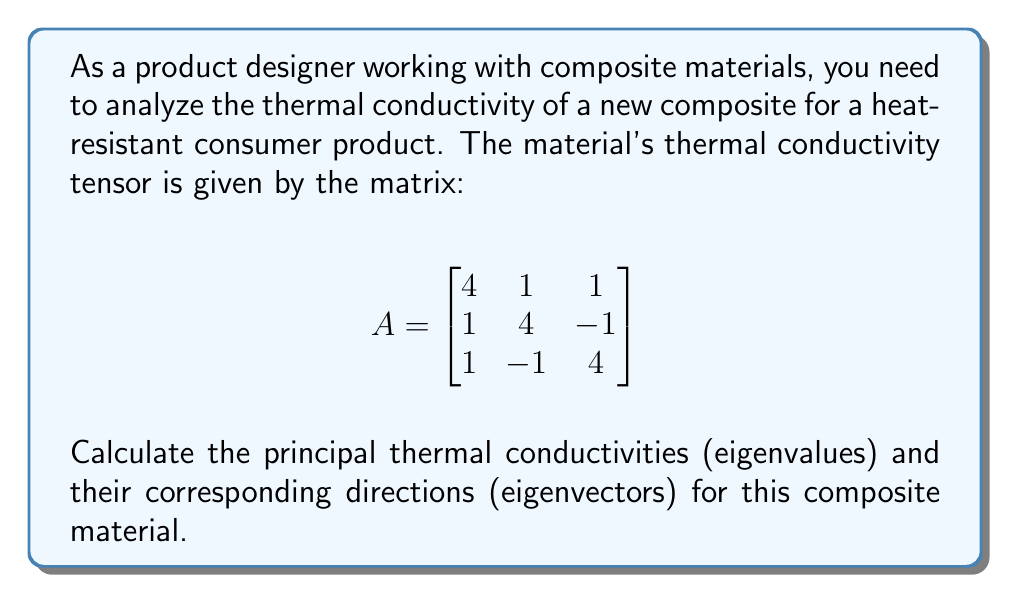Provide a solution to this math problem. To find the eigenvalues and eigenvectors of the thermal conductivity tensor, we follow these steps:

1) First, we need to solve the characteristic equation:
   $$det(A - \lambda I) = 0$$

2) Expanding this determinant:
   $$\begin{vmatrix}
   4-\lambda & 1 & 1 \\
   1 & 4-\lambda & -1 \\
   1 & -1 & 4-\lambda
   \end{vmatrix} = 0$$

3) This expands to:
   $$(4-\lambda)^3 + 2 - 3(4-\lambda) = 0$$
   $$\lambda^3 - 12\lambda^2 + 44\lambda - 48 = 0$$

4) Factoring this cubic equation:
   $$(\lambda - 2)(\lambda - 5)^2 = 0$$

5) So, the eigenvalues are:
   $$\lambda_1 = 2, \lambda_2 = \lambda_3 = 5$$

6) For each eigenvalue, we solve $(A - \lambda I)\mathbf{v} = \mathbf{0}$ to find the eigenvectors:

   For $\lambda_1 = 2$:
   $$\begin{bmatrix}
   2 & 1 & 1 \\
   1 & 2 & -1 \\
   1 & -1 & 2
   \end{bmatrix}\mathbf{v_1} = \mathbf{0}$$

   Solving this gives: $\mathbf{v_1} = \begin{bmatrix} 1 \\ -1 \\ 1 \end{bmatrix}$

   For $\lambda_2 = \lambda_3 = 5$:
   $$\begin{bmatrix}
   -1 & 1 & 1 \\
   1 & -1 & -1 \\
   1 & -1 & -1
   \end{bmatrix}\mathbf{v_2} = \mathbf{0}$$

   This gives two linearly independent eigenvectors:
   $\mathbf{v_2} = \begin{bmatrix} 1 \\ 1 \\ 0 \end{bmatrix}$ and
   $\mathbf{v_3} = \begin{bmatrix} 1 \\ 0 \\ 1 \end{bmatrix}$

7) Normalizing these eigenvectors:
   $\mathbf{v_1} = \frac{1}{\sqrt{3}}\begin{bmatrix} 1 \\ -1 \\ 1 \end{bmatrix}$
   $\mathbf{v_2} = \frac{1}{\sqrt{2}}\begin{bmatrix} 1 \\ 1 \\ 0 \end{bmatrix}$
   $\mathbf{v_3} = \frac{1}{\sqrt{2}}\begin{bmatrix} 1 \\ 0 \\ 1 \end{bmatrix}$
Answer: Principal thermal conductivities: 2, 5, 5
Corresponding directions: $\frac{1}{\sqrt{3}}(1,-1,1)$, $\frac{1}{\sqrt{2}}(1,1,0)$, $\frac{1}{\sqrt{2}}(1,0,1)$ 